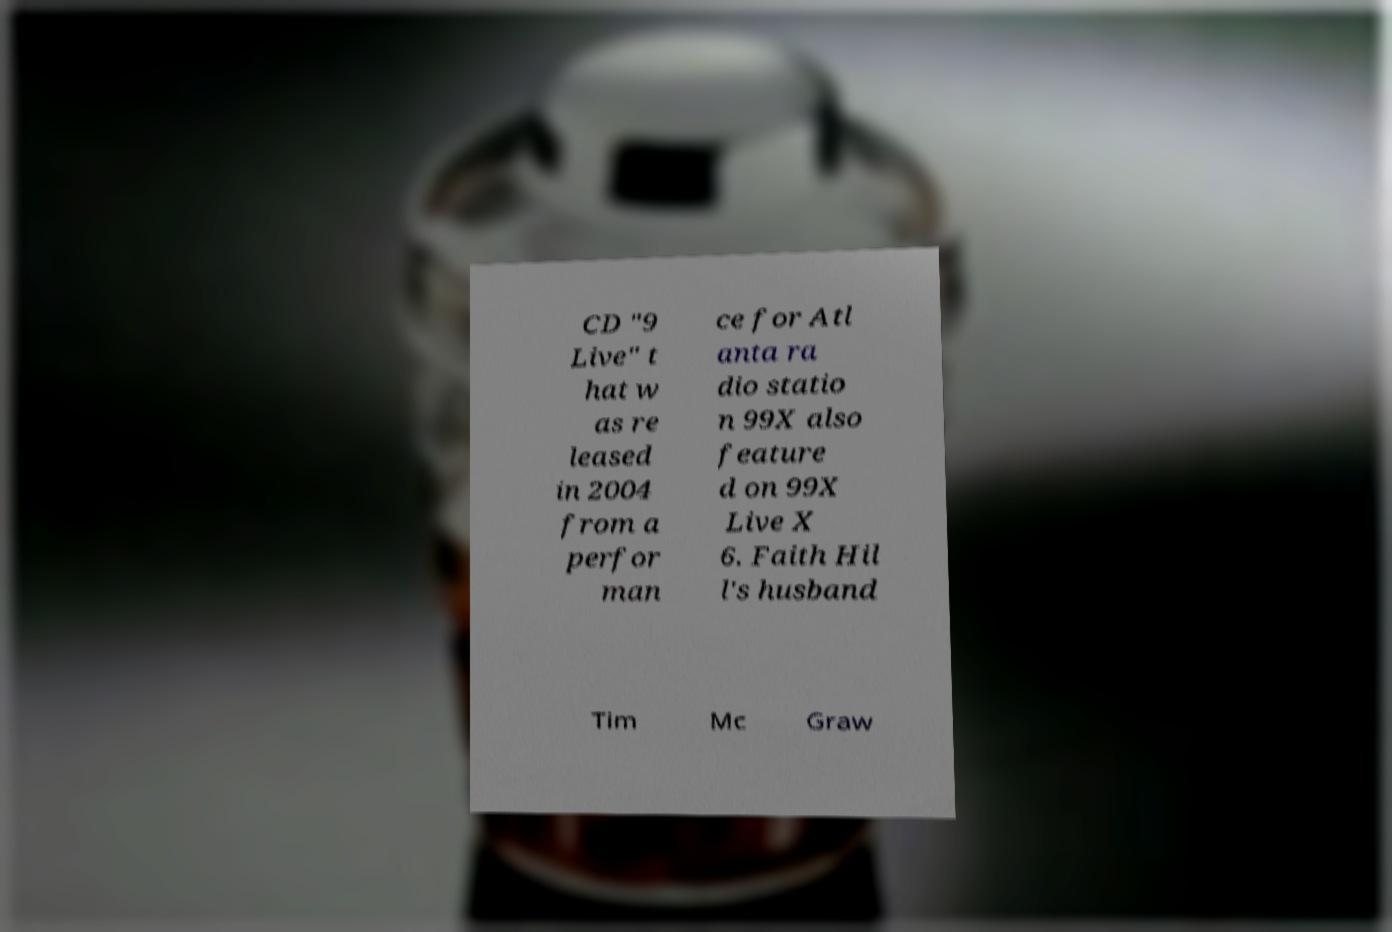Please identify and transcribe the text found in this image. CD "9 Live" t hat w as re leased in 2004 from a perfor man ce for Atl anta ra dio statio n 99X also feature d on 99X Live X 6. Faith Hil l's husband Tim Mc Graw 